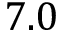<formula> <loc_0><loc_0><loc_500><loc_500>7 . 0</formula> 